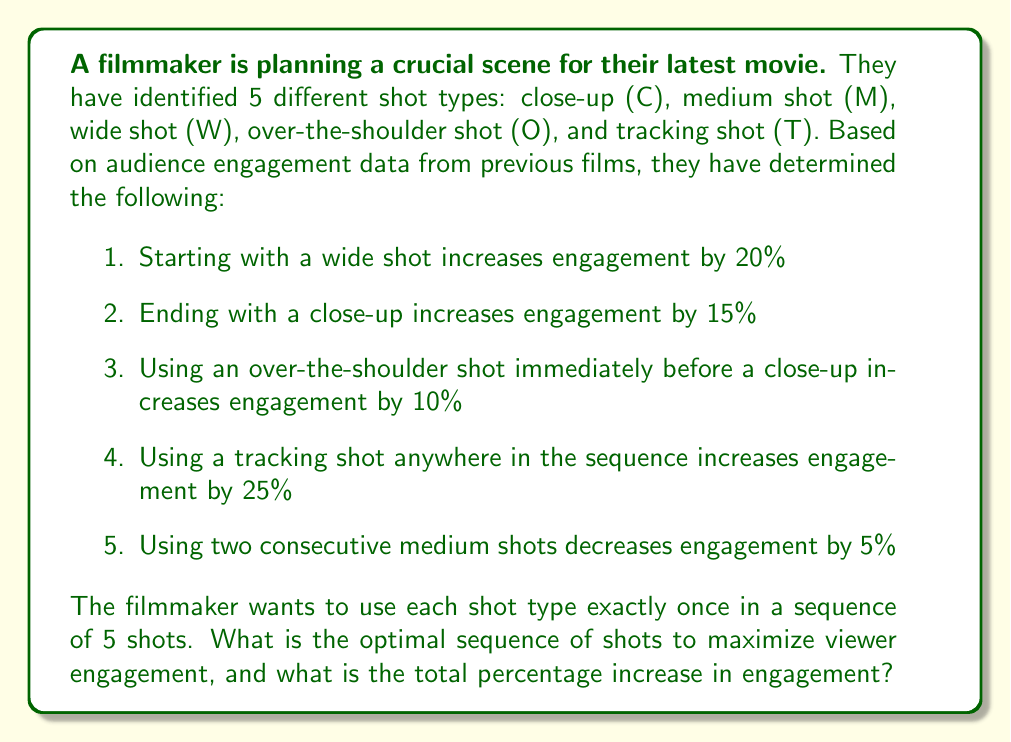Can you solve this math problem? To solve this problem, we need to consider all possible sequences of the 5 shot types and calculate the engagement increase for each sequence. Let's approach this step-by-step:

1. First, we know that starting with a wide shot (W) and ending with a close-up (C) will give us the highest engagement increase. This leaves us with 3! = 6 possible arrangements for the middle 3 shots.

2. We also know that we should include a tracking shot (T) somewhere in the sequence to get the 25% engagement increase.

3. To maximize engagement, we should place the over-the-shoulder shot (O) immediately before the close-up (C).

4. We should avoid placing two medium shots (M) next to each other.

Given these constraints, let's examine the possible sequences:

$$\text{W M O T C}$$
$$\text{W M T O C}$$
$$\text{W O M T C}$$
$$\text{W O T M C}$$
$$\text{W T M O C}$$
$$\text{W T O M C}$$

Now, let's calculate the engagement increase for each sequence:

1. W M O T C: 20% + 25% + 10% + 15% = 70%
2. W M T O C: 20% + 25% + 10% + 15% = 70%
3. W O M T C: 20% + 25% + 15% = 60%
4. W O T M C: 20% + 25% + 15% = 60%
5. W T M O C: 20% + 25% + 10% + 15% = 70%
6. W T O M C: 20% + 25% + 15% = 60%

We can see that there are three sequences that yield the maximum engagement increase of 70%:

$$\text{W M O T C}$$
$$\text{W M T O C}$$
$$\text{W T M O C}$$

Any of these sequences would be optimal for maximizing viewer engagement.
Answer: The optimal sequences of shots to maximize viewer engagement are:

W M O T C
W M T O C
W T M O C

The total percentage increase in engagement is 70%. 